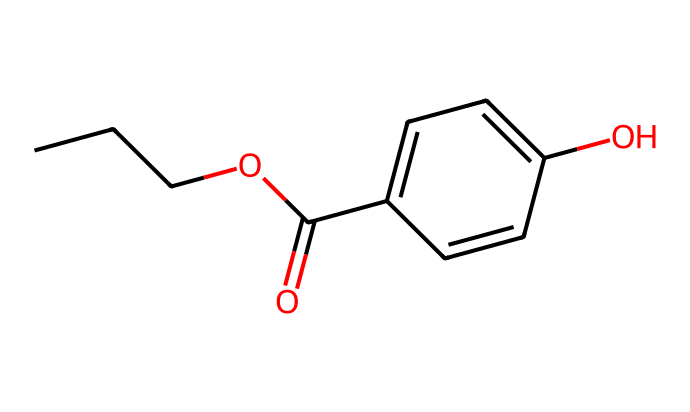How many carbon atoms are in propylparaben? The SMILES representation indicates the presence of "CCCO" which indicates a propyl group with three carbon atoms. Additionally, "C1=CC=C(O)" indicates another six carbon atoms in the aromatic ring. In total, there are 9 carbon atoms.
Answer: 9 What functional group is present in propylparaben? The "C(=O)" portion of the SMILES notation indicates a carbonyl group, and when combined with the "O" from "OC", it identifies this molecule as an ester functional group (specifically a paraben).
Answer: ester How many oxygen atoms are present in propylparaben? By evaluating the SMILES, there are two appearances of "O": one in "OC" and one in "C(=O)", resulting in a total of two oxygen atoms in the chemical structure.
Answer: 2 What is the primary purpose of propylparaben in cosmetics? Propylparaben serves as a preservative to prevent microbial growth and extend shelf life of cosmetics.
Answer: preservative What type of compound is propylparaben classified as in cosmetics? Due to its function primarily as a preservative and its structural characteristics, propylparaben is classified as a paraben, which is a widespread preservative type used in cosmetics.
Answer: paraben 